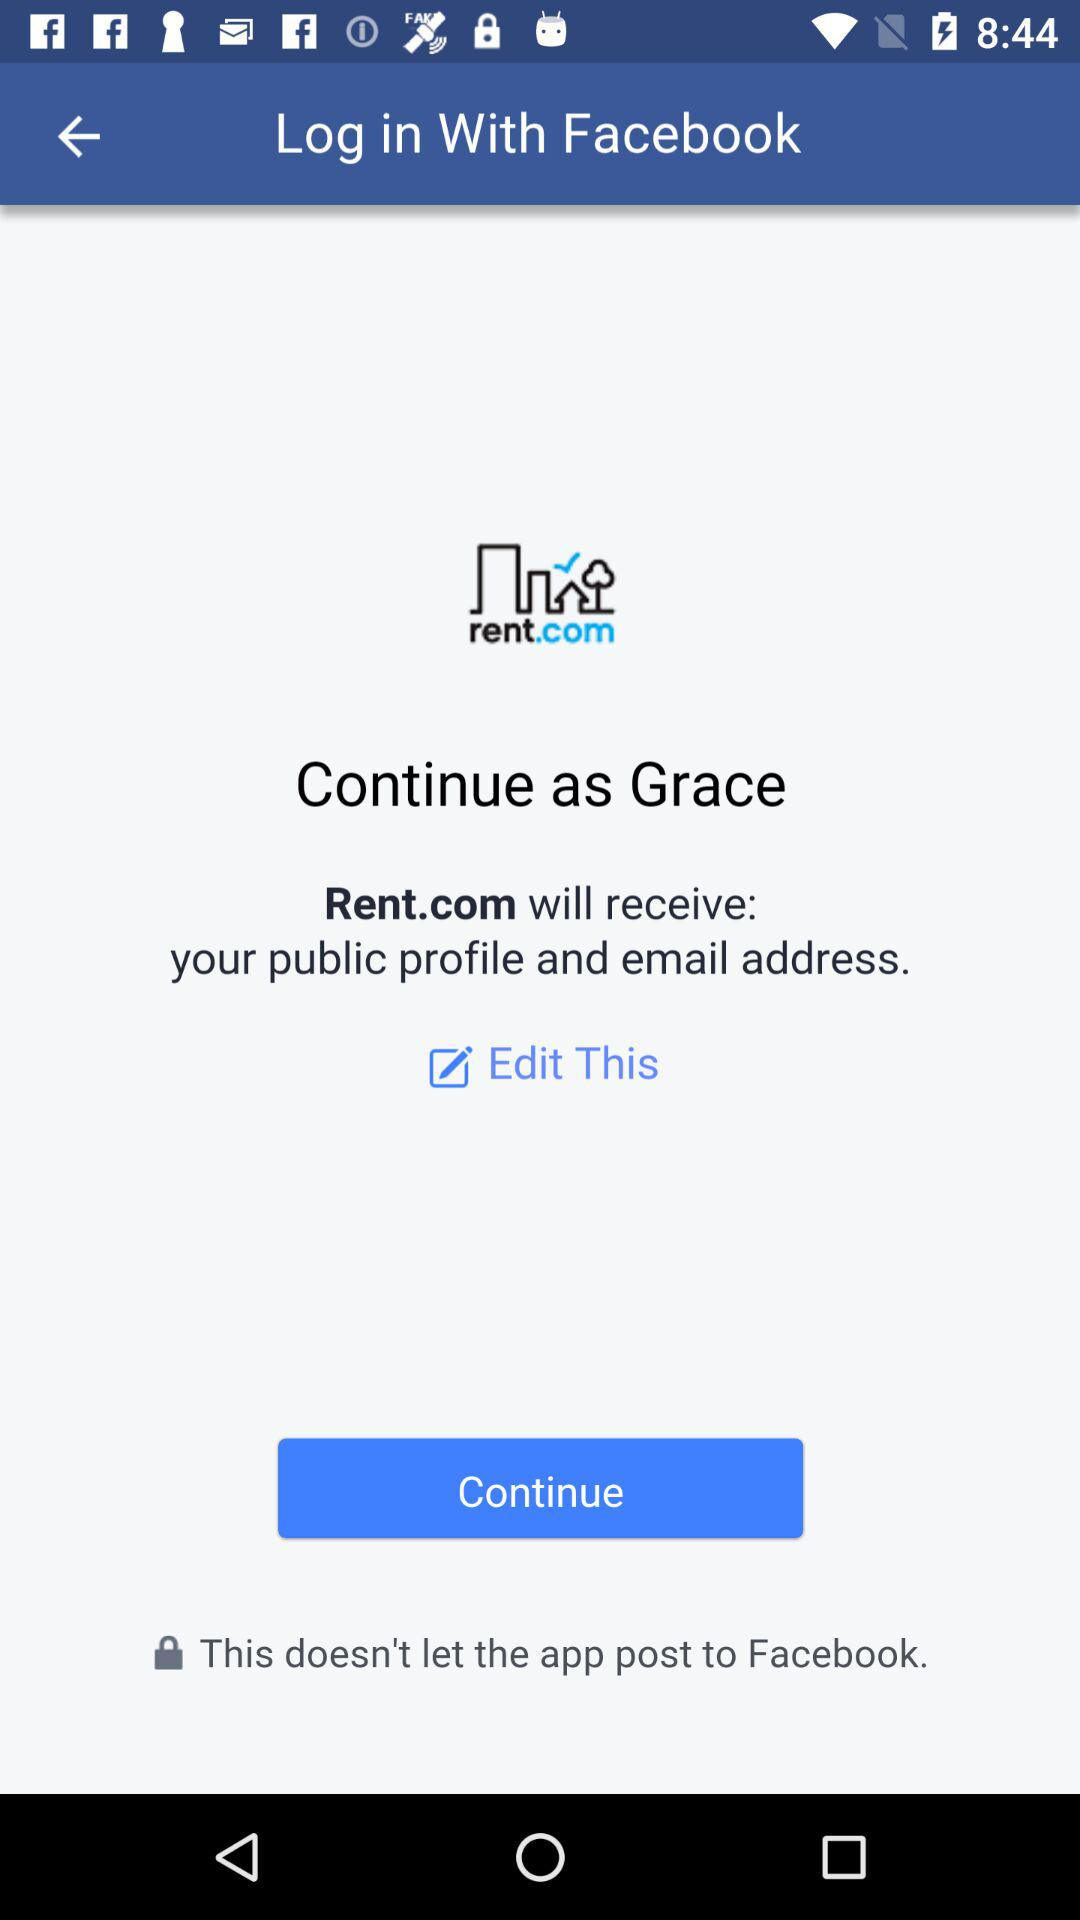What is Grace's last name?
When the provided information is insufficient, respond with <no answer>. <no answer> 